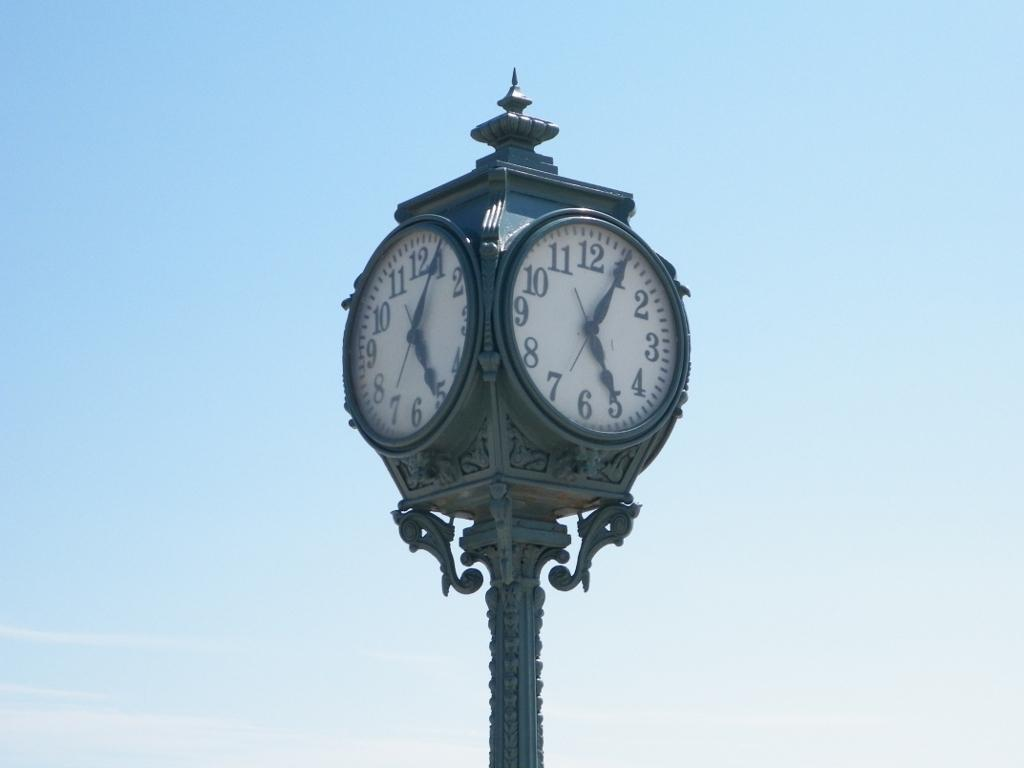Provide a one-sentence caption for the provided image. Tall clock with the hands at 1 and 5. 